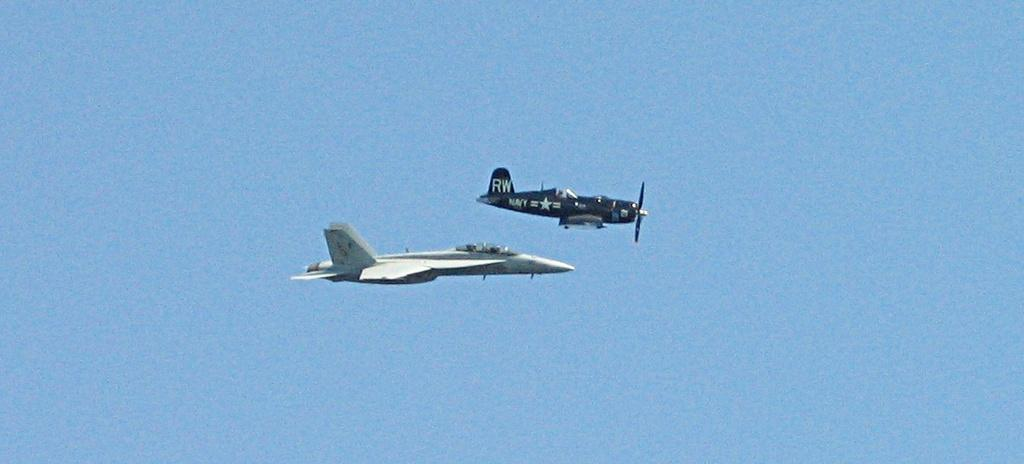What is the main subject of the image? The main subject of the image is airplanes. Where are the airplanes located in the image? The airplanes are in the sky. What type of trade is being conducted between the airplanes in the image? There is no indication of any trade being conducted between the airplanes in the image. Can you see any ships in the image? There are no ships present in the image; it only features airplanes in the sky. 